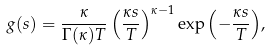Convert formula to latex. <formula><loc_0><loc_0><loc_500><loc_500>g ( s ) = \frac { \kappa } { \Gamma ( \kappa ) T } \left ( \frac { \kappa s } { T } \right ) ^ { \kappa - 1 } \exp { \left ( - \frac { \kappa s } { T } \right ) } ,</formula> 